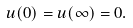<formula> <loc_0><loc_0><loc_500><loc_500>u ( 0 ) = u ( \infty ) = 0 .</formula> 